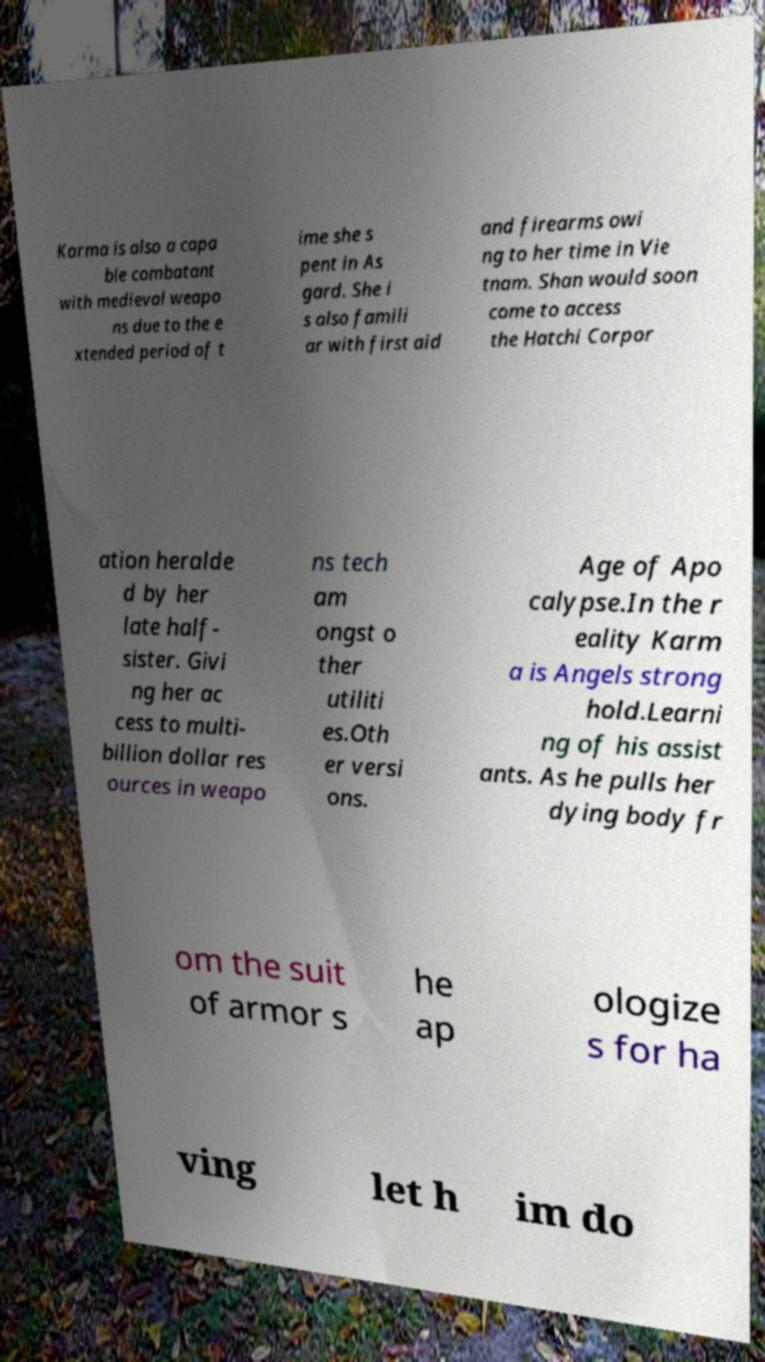Please read and relay the text visible in this image. What does it say? Karma is also a capa ble combatant with medieval weapo ns due to the e xtended period of t ime she s pent in As gard. She i s also famili ar with first aid and firearms owi ng to her time in Vie tnam. Shan would soon come to access the Hatchi Corpor ation heralde d by her late half- sister. Givi ng her ac cess to multi- billion dollar res ources in weapo ns tech am ongst o ther utiliti es.Oth er versi ons. Age of Apo calypse.In the r eality Karm a is Angels strong hold.Learni ng of his assist ants. As he pulls her dying body fr om the suit of armor s he ap ologize s for ha ving let h im do 